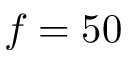Convert formula to latex. <formula><loc_0><loc_0><loc_500><loc_500>f = 5 0</formula> 